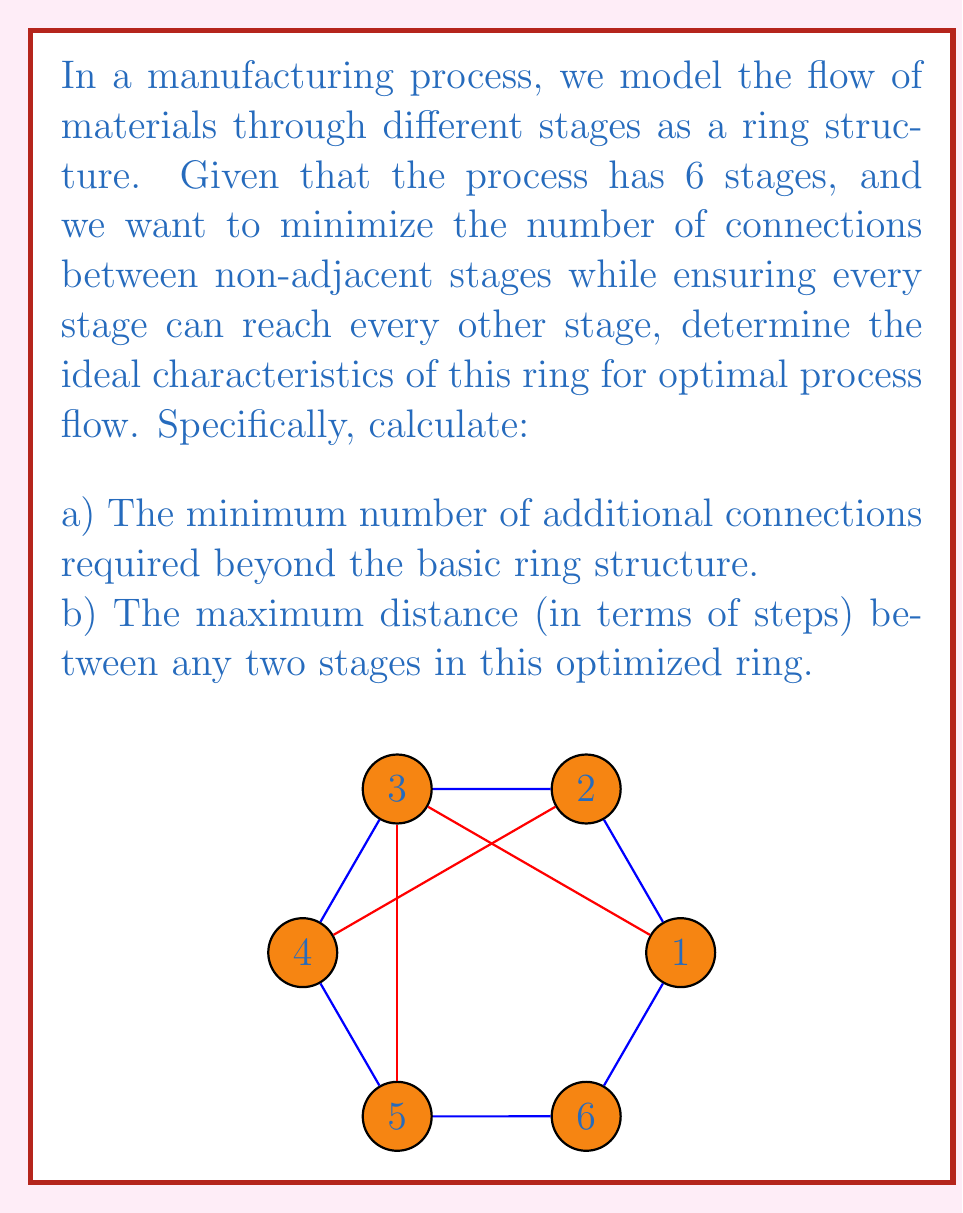Solve this math problem. Let's approach this step-by-step:

1) In a basic ring structure with 6 stages, each stage is connected to its two adjacent stages. This forms the outer circle in the diagram.

2) To optimize the process flow, we want to minimize additional connections while ensuring every stage can reach every other stage in the fewest steps possible.

3) In a ring with 6 stages, the maximum distance between any two stages without additional connections is 3 steps (half the ring).

4) To reduce this maximum distance, we need to add connections that "skip" stages. The most efficient way to do this is to connect each stage to the stage that's 3 steps away (opposite in the ring).

5) Calculating the number of additional connections:
   - Each stage needs one additional connection to its opposite.
   - There are 6 stages in total.
   - But each connection is counted twice (once from each end).
   - So, the number of additional connections = 6 ÷ 2 = 3

6) With these additional connections:
   - Any two adjacent stages are 1 step apart.
   - Any two stages with one stage between them are 2 steps apart (either around the ring or through the opposite stage).
   - The two stages furthest apart (e.g., 1 and 4) are now 2 steps apart (through the new connection).

Therefore, the maximum distance between any two stages in this optimized ring is 2 steps.
Answer: a) 3 additional connections
b) 2 steps 